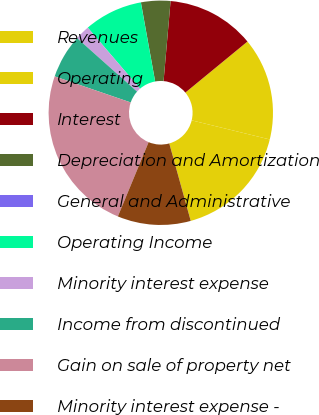Convert chart to OTSL. <chart><loc_0><loc_0><loc_500><loc_500><pie_chart><fcel>Revenues<fcel>Operating<fcel>Interest<fcel>Depreciation and Amortization<fcel>General and Administrative<fcel>Operating Income<fcel>Minority interest expense<fcel>Income from discontinued<fcel>Gain on sale of property net<fcel>Minority interest expense -<nl><fcel>16.88%<fcel>14.77%<fcel>12.66%<fcel>4.23%<fcel>0.01%<fcel>8.44%<fcel>2.12%<fcel>6.33%<fcel>24.01%<fcel>10.55%<nl></chart> 